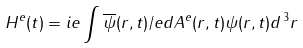Convert formula to latex. <formula><loc_0><loc_0><loc_500><loc_500>H ^ { e } ( t ) = i e \int \overline { \psi } ( r , t ) \slash e d { A } ^ { e } ( r , t ) \psi ( r , t ) d ^ { \, 3 } r</formula> 